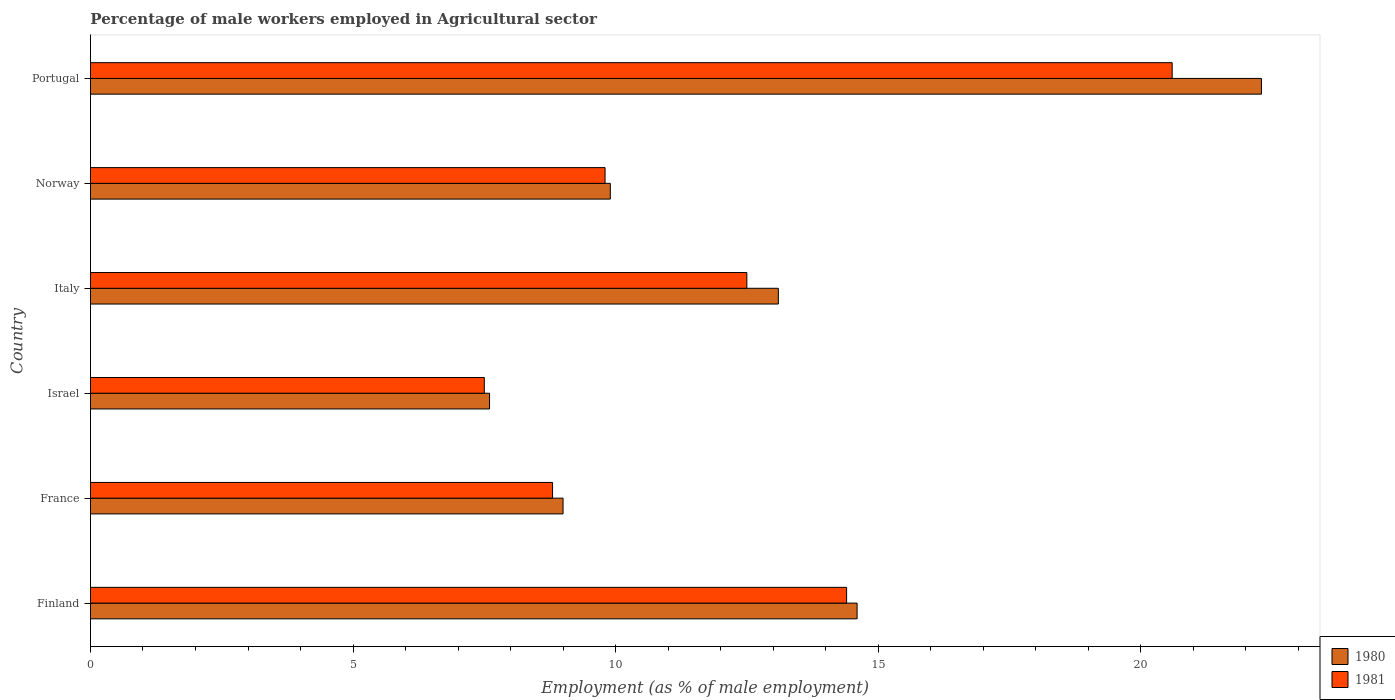How many different coloured bars are there?
Give a very brief answer. 2. Are the number of bars on each tick of the Y-axis equal?
Provide a short and direct response. Yes. How many bars are there on the 2nd tick from the top?
Ensure brevity in your answer.  2. How many bars are there on the 2nd tick from the bottom?
Your answer should be very brief. 2. What is the percentage of male workers employed in Agricultural sector in 1980 in Israel?
Provide a succinct answer. 7.6. Across all countries, what is the maximum percentage of male workers employed in Agricultural sector in 1981?
Keep it short and to the point. 20.6. Across all countries, what is the minimum percentage of male workers employed in Agricultural sector in 1981?
Ensure brevity in your answer.  7.5. In which country was the percentage of male workers employed in Agricultural sector in 1980 maximum?
Ensure brevity in your answer.  Portugal. In which country was the percentage of male workers employed in Agricultural sector in 1980 minimum?
Your response must be concise. Israel. What is the total percentage of male workers employed in Agricultural sector in 1980 in the graph?
Ensure brevity in your answer.  76.5. What is the difference between the percentage of male workers employed in Agricultural sector in 1981 in Finland and the percentage of male workers employed in Agricultural sector in 1980 in Israel?
Make the answer very short. 6.8. What is the average percentage of male workers employed in Agricultural sector in 1980 per country?
Make the answer very short. 12.75. What is the difference between the percentage of male workers employed in Agricultural sector in 1981 and percentage of male workers employed in Agricultural sector in 1980 in Finland?
Provide a short and direct response. -0.2. What is the ratio of the percentage of male workers employed in Agricultural sector in 1980 in Finland to that in France?
Make the answer very short. 1.62. Is the percentage of male workers employed in Agricultural sector in 1981 in Finland less than that in Israel?
Provide a short and direct response. No. Is the difference between the percentage of male workers employed in Agricultural sector in 1981 in Finland and Portugal greater than the difference between the percentage of male workers employed in Agricultural sector in 1980 in Finland and Portugal?
Offer a terse response. Yes. What is the difference between the highest and the second highest percentage of male workers employed in Agricultural sector in 1981?
Keep it short and to the point. 6.2. What is the difference between the highest and the lowest percentage of male workers employed in Agricultural sector in 1980?
Your response must be concise. 14.7. Is the sum of the percentage of male workers employed in Agricultural sector in 1981 in Israel and Italy greater than the maximum percentage of male workers employed in Agricultural sector in 1980 across all countries?
Your answer should be very brief. No. What does the 1st bar from the bottom in Israel represents?
Give a very brief answer. 1980. How many bars are there?
Give a very brief answer. 12. What is the difference between two consecutive major ticks on the X-axis?
Offer a very short reply. 5. How many legend labels are there?
Your response must be concise. 2. How are the legend labels stacked?
Provide a short and direct response. Vertical. What is the title of the graph?
Offer a terse response. Percentage of male workers employed in Agricultural sector. What is the label or title of the X-axis?
Provide a short and direct response. Employment (as % of male employment). What is the Employment (as % of male employment) of 1980 in Finland?
Keep it short and to the point. 14.6. What is the Employment (as % of male employment) in 1981 in Finland?
Provide a succinct answer. 14.4. What is the Employment (as % of male employment) of 1981 in France?
Keep it short and to the point. 8.8. What is the Employment (as % of male employment) in 1980 in Israel?
Make the answer very short. 7.6. What is the Employment (as % of male employment) of 1981 in Israel?
Offer a terse response. 7.5. What is the Employment (as % of male employment) in 1980 in Italy?
Your response must be concise. 13.1. What is the Employment (as % of male employment) in 1980 in Norway?
Ensure brevity in your answer.  9.9. What is the Employment (as % of male employment) in 1981 in Norway?
Your response must be concise. 9.8. What is the Employment (as % of male employment) of 1980 in Portugal?
Provide a short and direct response. 22.3. What is the Employment (as % of male employment) of 1981 in Portugal?
Provide a succinct answer. 20.6. Across all countries, what is the maximum Employment (as % of male employment) of 1980?
Provide a succinct answer. 22.3. Across all countries, what is the maximum Employment (as % of male employment) in 1981?
Give a very brief answer. 20.6. Across all countries, what is the minimum Employment (as % of male employment) of 1980?
Provide a succinct answer. 7.6. What is the total Employment (as % of male employment) in 1980 in the graph?
Provide a short and direct response. 76.5. What is the total Employment (as % of male employment) of 1981 in the graph?
Your response must be concise. 73.6. What is the difference between the Employment (as % of male employment) in 1980 in Finland and that in France?
Ensure brevity in your answer.  5.6. What is the difference between the Employment (as % of male employment) of 1981 in Finland and that in France?
Offer a very short reply. 5.6. What is the difference between the Employment (as % of male employment) in 1980 in Finland and that in Israel?
Your response must be concise. 7. What is the difference between the Employment (as % of male employment) of 1980 in Finland and that in Italy?
Keep it short and to the point. 1.5. What is the difference between the Employment (as % of male employment) of 1980 in Finland and that in Portugal?
Offer a very short reply. -7.7. What is the difference between the Employment (as % of male employment) in 1980 in France and that in Israel?
Provide a succinct answer. 1.4. What is the difference between the Employment (as % of male employment) of 1981 in France and that in Israel?
Offer a terse response. 1.3. What is the difference between the Employment (as % of male employment) of 1980 in France and that in Italy?
Your answer should be very brief. -4.1. What is the difference between the Employment (as % of male employment) in 1980 in France and that in Norway?
Make the answer very short. -0.9. What is the difference between the Employment (as % of male employment) in 1981 in France and that in Norway?
Make the answer very short. -1. What is the difference between the Employment (as % of male employment) of 1980 in France and that in Portugal?
Give a very brief answer. -13.3. What is the difference between the Employment (as % of male employment) of 1980 in Israel and that in Italy?
Give a very brief answer. -5.5. What is the difference between the Employment (as % of male employment) of 1980 in Israel and that in Norway?
Make the answer very short. -2.3. What is the difference between the Employment (as % of male employment) in 1981 in Israel and that in Norway?
Your answer should be compact. -2.3. What is the difference between the Employment (as % of male employment) in 1980 in Israel and that in Portugal?
Your answer should be compact. -14.7. What is the difference between the Employment (as % of male employment) of 1981 in Israel and that in Portugal?
Provide a short and direct response. -13.1. What is the difference between the Employment (as % of male employment) in 1981 in Italy and that in Norway?
Keep it short and to the point. 2.7. What is the difference between the Employment (as % of male employment) of 1980 in Italy and that in Portugal?
Offer a very short reply. -9.2. What is the difference between the Employment (as % of male employment) of 1981 in Italy and that in Portugal?
Your response must be concise. -8.1. What is the difference between the Employment (as % of male employment) of 1980 in Norway and that in Portugal?
Ensure brevity in your answer.  -12.4. What is the difference between the Employment (as % of male employment) of 1980 in Finland and the Employment (as % of male employment) of 1981 in Israel?
Keep it short and to the point. 7.1. What is the difference between the Employment (as % of male employment) of 1980 in Finland and the Employment (as % of male employment) of 1981 in Portugal?
Offer a terse response. -6. What is the difference between the Employment (as % of male employment) of 1980 in France and the Employment (as % of male employment) of 1981 in Norway?
Make the answer very short. -0.8. What is the difference between the Employment (as % of male employment) of 1980 in France and the Employment (as % of male employment) of 1981 in Portugal?
Your response must be concise. -11.6. What is the difference between the Employment (as % of male employment) of 1980 in Israel and the Employment (as % of male employment) of 1981 in Italy?
Your answer should be compact. -4.9. What is the difference between the Employment (as % of male employment) of 1980 in Israel and the Employment (as % of male employment) of 1981 in Portugal?
Your answer should be very brief. -13. What is the difference between the Employment (as % of male employment) of 1980 in Italy and the Employment (as % of male employment) of 1981 in Norway?
Your response must be concise. 3.3. What is the difference between the Employment (as % of male employment) of 1980 in Italy and the Employment (as % of male employment) of 1981 in Portugal?
Provide a succinct answer. -7.5. What is the difference between the Employment (as % of male employment) of 1980 in Norway and the Employment (as % of male employment) of 1981 in Portugal?
Give a very brief answer. -10.7. What is the average Employment (as % of male employment) of 1980 per country?
Your response must be concise. 12.75. What is the average Employment (as % of male employment) in 1981 per country?
Provide a succinct answer. 12.27. What is the difference between the Employment (as % of male employment) in 1980 and Employment (as % of male employment) in 1981 in Finland?
Give a very brief answer. 0.2. What is the difference between the Employment (as % of male employment) in 1980 and Employment (as % of male employment) in 1981 in France?
Ensure brevity in your answer.  0.2. What is the difference between the Employment (as % of male employment) of 1980 and Employment (as % of male employment) of 1981 in Israel?
Offer a terse response. 0.1. What is the difference between the Employment (as % of male employment) in 1980 and Employment (as % of male employment) in 1981 in Italy?
Offer a very short reply. 0.6. What is the difference between the Employment (as % of male employment) of 1980 and Employment (as % of male employment) of 1981 in Norway?
Offer a terse response. 0.1. What is the ratio of the Employment (as % of male employment) in 1980 in Finland to that in France?
Offer a very short reply. 1.62. What is the ratio of the Employment (as % of male employment) in 1981 in Finland to that in France?
Ensure brevity in your answer.  1.64. What is the ratio of the Employment (as % of male employment) in 1980 in Finland to that in Israel?
Offer a terse response. 1.92. What is the ratio of the Employment (as % of male employment) in 1981 in Finland to that in Israel?
Offer a terse response. 1.92. What is the ratio of the Employment (as % of male employment) of 1980 in Finland to that in Italy?
Offer a terse response. 1.11. What is the ratio of the Employment (as % of male employment) of 1981 in Finland to that in Italy?
Your answer should be compact. 1.15. What is the ratio of the Employment (as % of male employment) in 1980 in Finland to that in Norway?
Your response must be concise. 1.47. What is the ratio of the Employment (as % of male employment) of 1981 in Finland to that in Norway?
Provide a succinct answer. 1.47. What is the ratio of the Employment (as % of male employment) of 1980 in Finland to that in Portugal?
Offer a very short reply. 0.65. What is the ratio of the Employment (as % of male employment) of 1981 in Finland to that in Portugal?
Provide a short and direct response. 0.7. What is the ratio of the Employment (as % of male employment) of 1980 in France to that in Israel?
Your answer should be very brief. 1.18. What is the ratio of the Employment (as % of male employment) of 1981 in France to that in Israel?
Keep it short and to the point. 1.17. What is the ratio of the Employment (as % of male employment) in 1980 in France to that in Italy?
Your answer should be compact. 0.69. What is the ratio of the Employment (as % of male employment) of 1981 in France to that in Italy?
Provide a short and direct response. 0.7. What is the ratio of the Employment (as % of male employment) in 1981 in France to that in Norway?
Your response must be concise. 0.9. What is the ratio of the Employment (as % of male employment) of 1980 in France to that in Portugal?
Ensure brevity in your answer.  0.4. What is the ratio of the Employment (as % of male employment) in 1981 in France to that in Portugal?
Provide a succinct answer. 0.43. What is the ratio of the Employment (as % of male employment) of 1980 in Israel to that in Italy?
Provide a short and direct response. 0.58. What is the ratio of the Employment (as % of male employment) of 1981 in Israel to that in Italy?
Make the answer very short. 0.6. What is the ratio of the Employment (as % of male employment) in 1980 in Israel to that in Norway?
Keep it short and to the point. 0.77. What is the ratio of the Employment (as % of male employment) of 1981 in Israel to that in Norway?
Keep it short and to the point. 0.77. What is the ratio of the Employment (as % of male employment) in 1980 in Israel to that in Portugal?
Ensure brevity in your answer.  0.34. What is the ratio of the Employment (as % of male employment) of 1981 in Israel to that in Portugal?
Ensure brevity in your answer.  0.36. What is the ratio of the Employment (as % of male employment) of 1980 in Italy to that in Norway?
Make the answer very short. 1.32. What is the ratio of the Employment (as % of male employment) in 1981 in Italy to that in Norway?
Ensure brevity in your answer.  1.28. What is the ratio of the Employment (as % of male employment) in 1980 in Italy to that in Portugal?
Your answer should be compact. 0.59. What is the ratio of the Employment (as % of male employment) in 1981 in Italy to that in Portugal?
Keep it short and to the point. 0.61. What is the ratio of the Employment (as % of male employment) in 1980 in Norway to that in Portugal?
Provide a succinct answer. 0.44. What is the ratio of the Employment (as % of male employment) of 1981 in Norway to that in Portugal?
Keep it short and to the point. 0.48. 